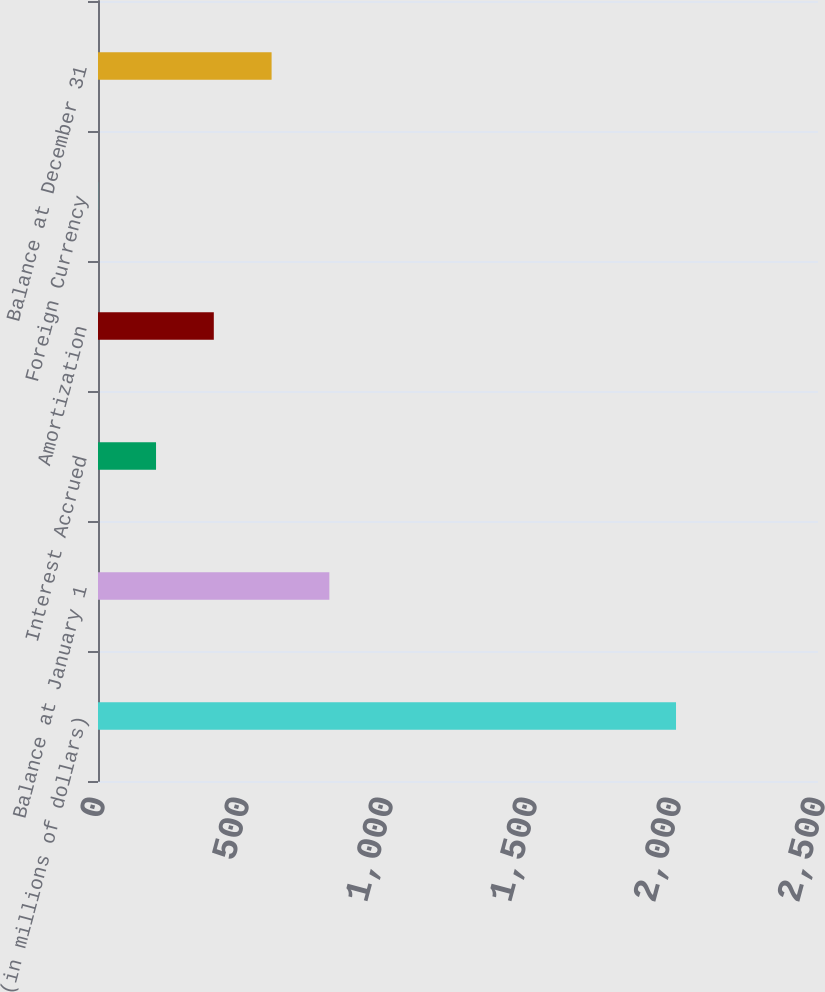<chart> <loc_0><loc_0><loc_500><loc_500><bar_chart><fcel>(in millions of dollars)<fcel>Balance at January 1<fcel>Interest Accrued<fcel>Amortization<fcel>Foreign Currency<fcel>Balance at December 31<nl><fcel>2007<fcel>803.34<fcel>201.51<fcel>402.12<fcel>0.9<fcel>602.73<nl></chart> 